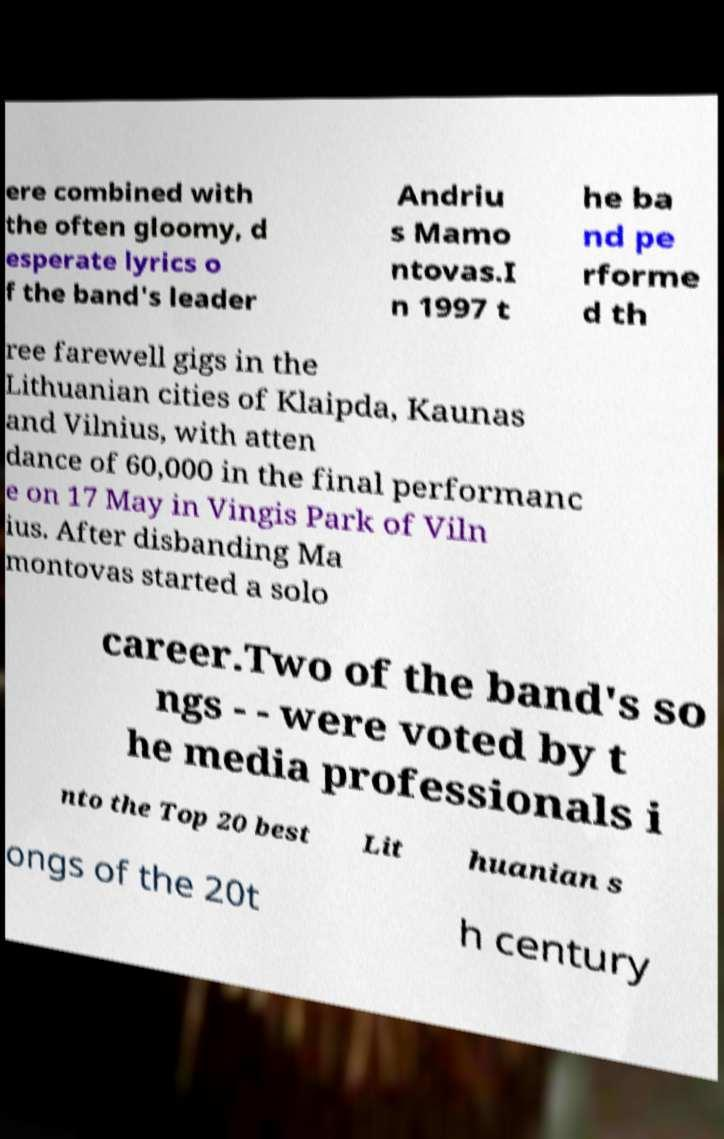Can you accurately transcribe the text from the provided image for me? ere combined with the often gloomy, d esperate lyrics o f the band's leader Andriu s Mamo ntovas.I n 1997 t he ba nd pe rforme d th ree farewell gigs in the Lithuanian cities of Klaipda, Kaunas and Vilnius, with atten dance of 60,000 in the final performanc e on 17 May in Vingis Park of Viln ius. After disbanding Ma montovas started a solo career.Two of the band's so ngs - - were voted by t he media professionals i nto the Top 20 best Lit huanian s ongs of the 20t h century 